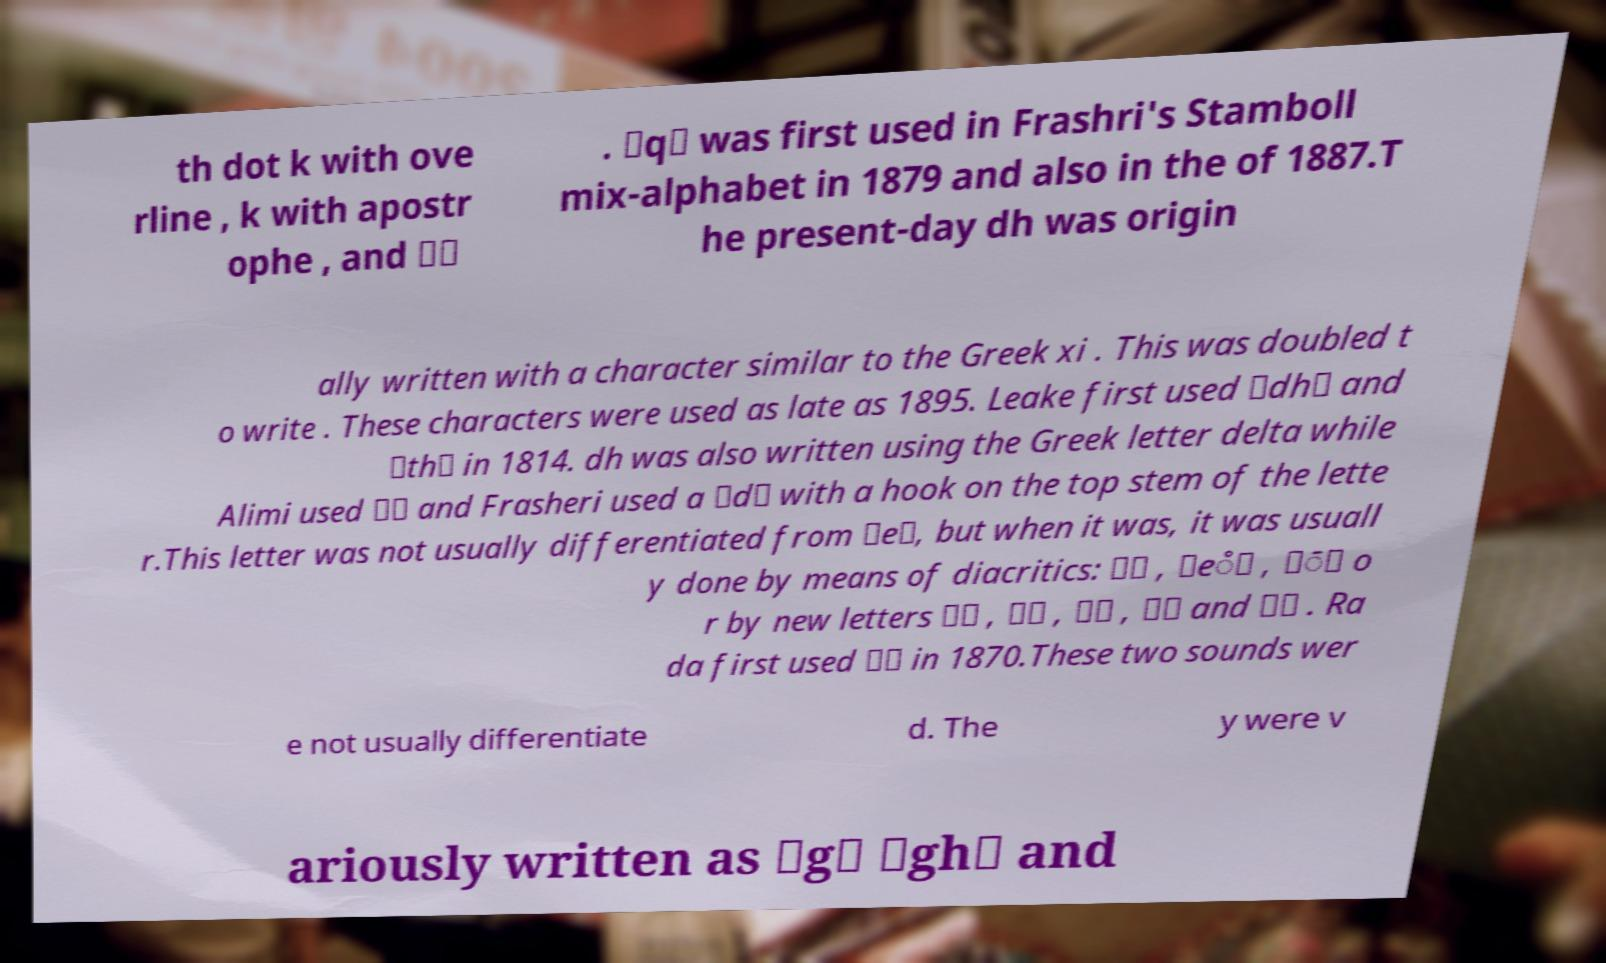There's text embedded in this image that I need extracted. Can you transcribe it verbatim? th dot k with ove rline , k with apostr ophe , and ⟨⟩ . ⟨q⟩ was first used in Frashri's Stamboll mix-alphabet in 1879 and also in the of 1887.T he present-day dh was origin ally written with a character similar to the Greek xi . This was doubled t o write . These characters were used as late as 1895. Leake first used ⟨dh⟩ and ⟨th⟩ in 1814. dh was also written using the Greek letter delta while Alimi used ⟨⟩ and Frasheri used a ⟨d⟩ with a hook on the top stem of the lette r.This letter was not usually differentiated from ⟨e⟩, but when it was, it was usuall y done by means of diacritics: ⟨⟩ , ⟨e̊⟩ , ⟨̄⟩ o r by new letters ⟨⟩ , ⟨⟩ , ⟨⟩ , ⟨⟩ and ⟨⟩ . Ra da first used ⟨⟩ in 1870.These two sounds wer e not usually differentiate d. The y were v ariously written as ⟨g⟩ ⟨gh⟩ and 